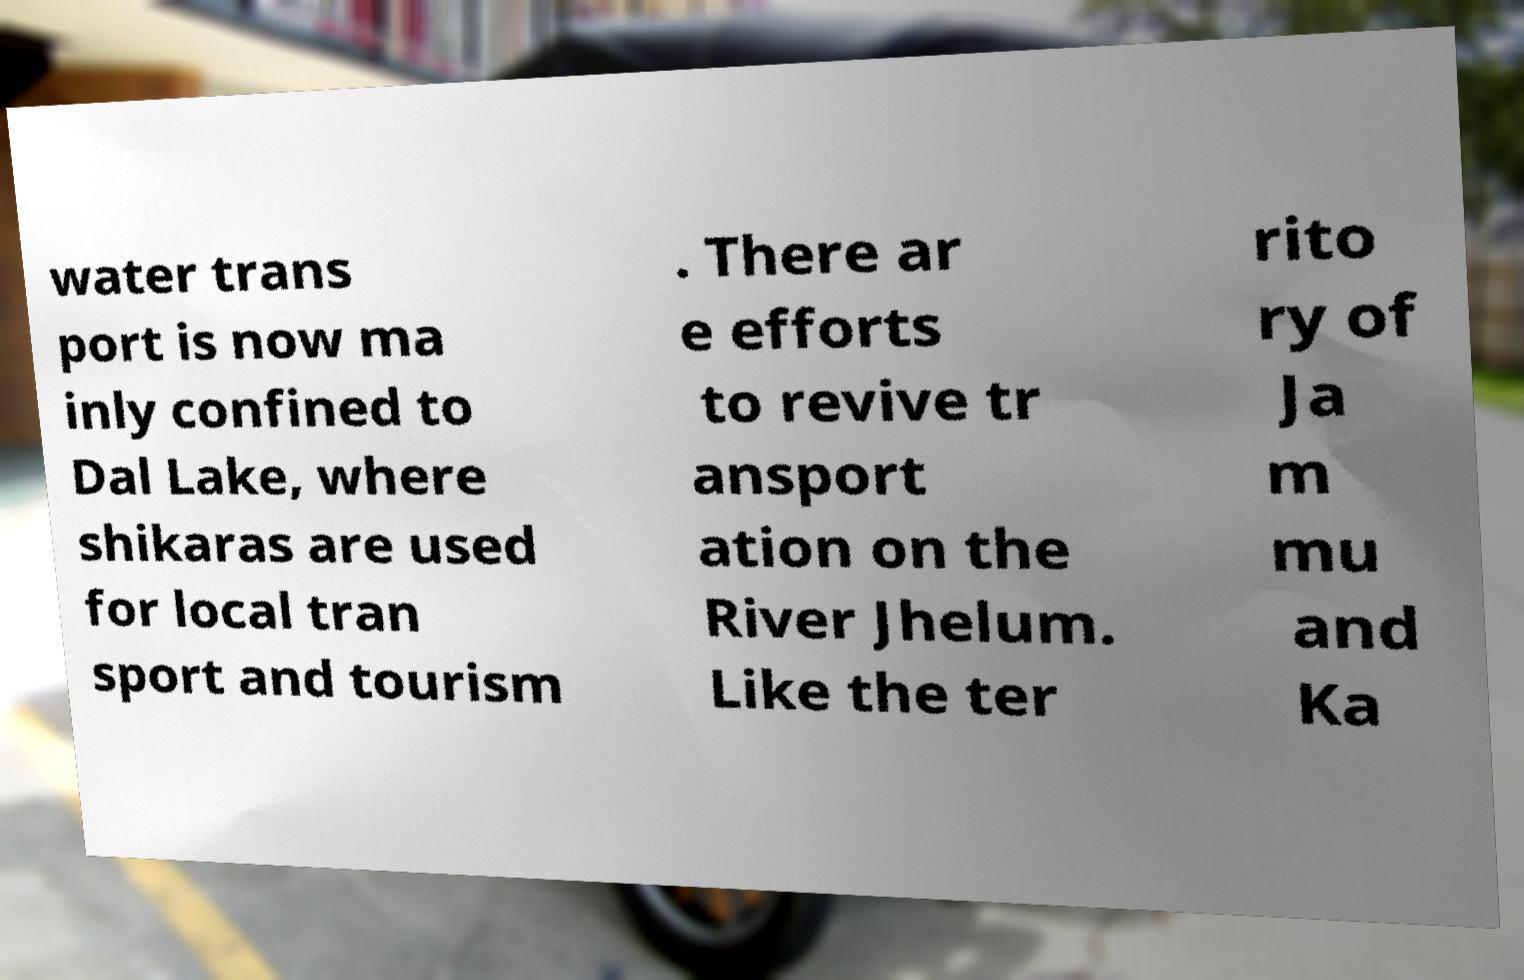There's text embedded in this image that I need extracted. Can you transcribe it verbatim? water trans port is now ma inly confined to Dal Lake, where shikaras are used for local tran sport and tourism . There ar e efforts to revive tr ansport ation on the River Jhelum. Like the ter rito ry of Ja m mu and Ka 